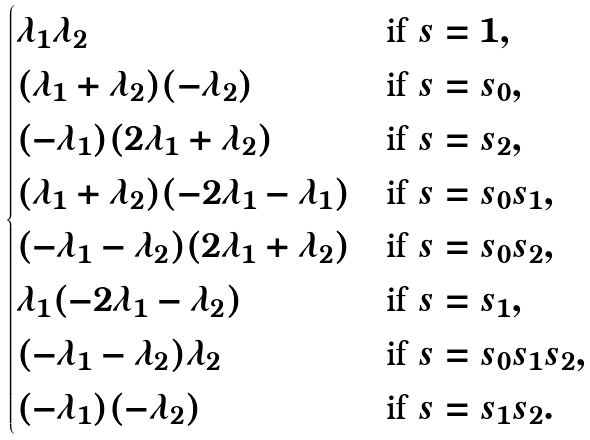Convert formula to latex. <formula><loc_0><loc_0><loc_500><loc_500>\begin{cases} \lambda _ { 1 } \lambda _ { 2 } & \text {if $s=1$} , \\ ( \lambda _ { 1 } + \lambda _ { 2 } ) ( - \lambda _ { 2 } ) & \text {if $s=s_{0}$} , \\ ( - \lambda _ { 1 } ) ( 2 \lambda _ { 1 } + \lambda _ { 2 } ) & \text {if $s=s_{2}$} , \\ ( \lambda _ { 1 } + \lambda _ { 2 } ) ( - 2 \lambda _ { 1 } - \lambda _ { 1 } ) & \text {if $s=s_{0}s_{1}$} , \\ ( - \lambda _ { 1 } - \lambda _ { 2 } ) ( 2 \lambda _ { 1 } + \lambda _ { 2 } ) & \text {if $s=s_{0}s_{2}$} , \\ \lambda _ { 1 } ( - 2 \lambda _ { 1 } - \lambda _ { 2 } ) & \text {if $s=s_{1}$} , \\ ( - \lambda _ { 1 } - \lambda _ { 2 } ) \lambda _ { 2 } & \text {if $s=s_{0}s_{1}s_{2}$} , \\ ( - \lambda _ { 1 } ) ( - \lambda _ { 2 } ) & \text {if $s=s_{1}s_{2}$} . \end{cases}</formula> 